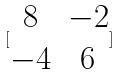<formula> <loc_0><loc_0><loc_500><loc_500>[ \begin{matrix} 8 & - 2 \\ - 4 & 6 \end{matrix} ]</formula> 